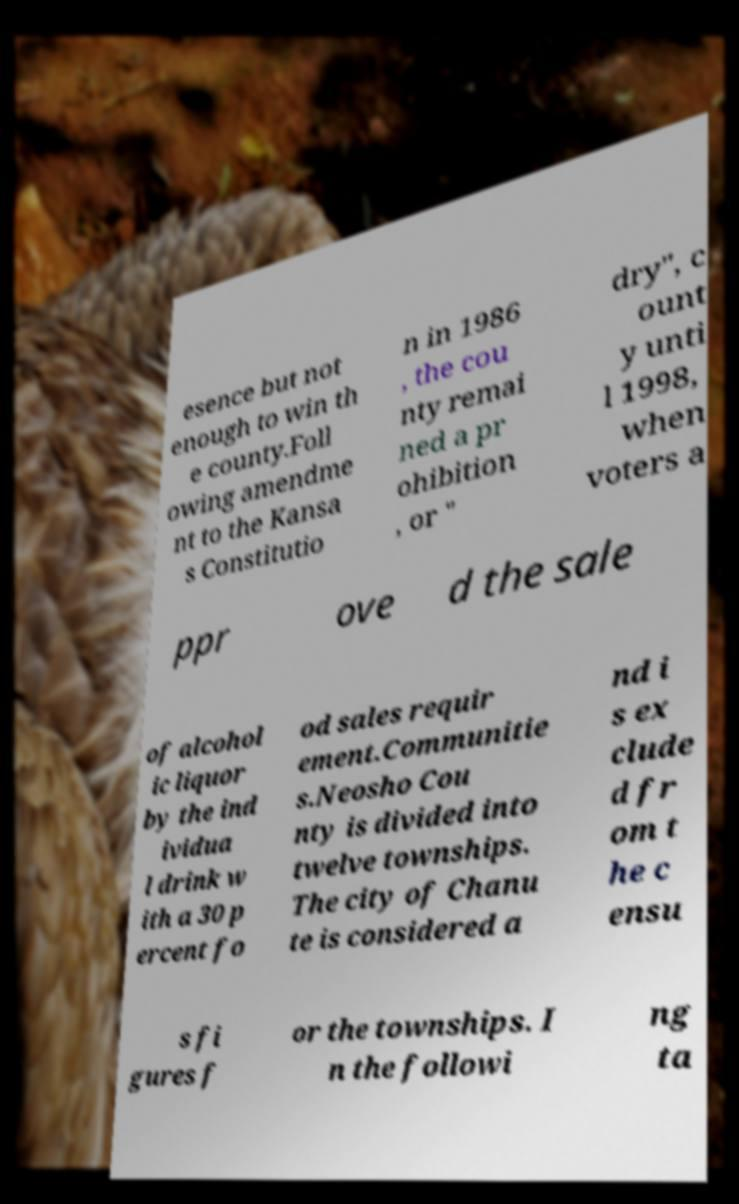For documentation purposes, I need the text within this image transcribed. Could you provide that? esence but not enough to win th e county.Foll owing amendme nt to the Kansa s Constitutio n in 1986 , the cou nty remai ned a pr ohibition , or " dry", c ount y unti l 1998, when voters a ppr ove d the sale of alcohol ic liquor by the ind ividua l drink w ith a 30 p ercent fo od sales requir ement.Communitie s.Neosho Cou nty is divided into twelve townships. The city of Chanu te is considered a nd i s ex clude d fr om t he c ensu s fi gures f or the townships. I n the followi ng ta 